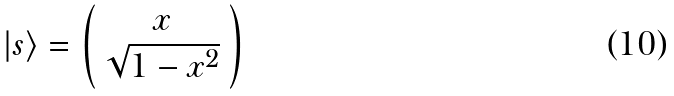Convert formula to latex. <formula><loc_0><loc_0><loc_500><loc_500>| s \rangle = \left ( \begin{array} { c c c } x \\ \sqrt { 1 - x ^ { 2 } } \end{array} \right )</formula> 